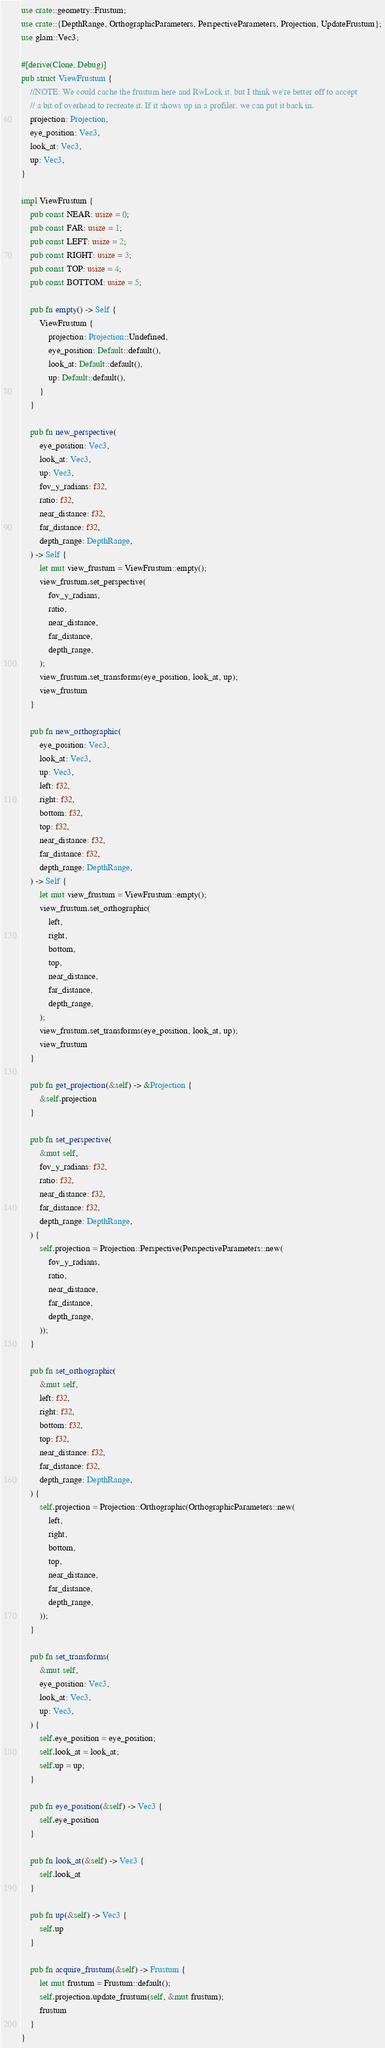<code> <loc_0><loc_0><loc_500><loc_500><_Rust_>use crate::geometry::Frustum;
use crate::{DepthRange, OrthographicParameters, PerspectiveParameters, Projection, UpdateFrustum};
use glam::Vec3;

#[derive(Clone, Debug)]
pub struct ViewFrustum {
    //NOTE: We could cache the frustum here and RwLock it, but I think we're better off to accept
    // a bit of overhead to recreate it. If it shows up in a profiler, we can put it back in.
    projection: Projection,
    eye_position: Vec3,
    look_at: Vec3,
    up: Vec3,
}

impl ViewFrustum {
    pub const NEAR: usize = 0;
    pub const FAR: usize = 1;
    pub const LEFT: usize = 2;
    pub const RIGHT: usize = 3;
    pub const TOP: usize = 4;
    pub const BOTTOM: usize = 5;

    pub fn empty() -> Self {
        ViewFrustum {
            projection: Projection::Undefined,
            eye_position: Default::default(),
            look_at: Default::default(),
            up: Default::default(),
        }
    }

    pub fn new_perspective(
        eye_position: Vec3,
        look_at: Vec3,
        up: Vec3,
        fov_y_radians: f32,
        ratio: f32,
        near_distance: f32,
        far_distance: f32,
        depth_range: DepthRange,
    ) -> Self {
        let mut view_frustum = ViewFrustum::empty();
        view_frustum.set_perspective(
            fov_y_radians,
            ratio,
            near_distance,
            far_distance,
            depth_range,
        );
        view_frustum.set_transforms(eye_position, look_at, up);
        view_frustum
    }

    pub fn new_orthographic(
        eye_position: Vec3,
        look_at: Vec3,
        up: Vec3,
        left: f32,
        right: f32,
        bottom: f32,
        top: f32,
        near_distance: f32,
        far_distance: f32,
        depth_range: DepthRange,
    ) -> Self {
        let mut view_frustum = ViewFrustum::empty();
        view_frustum.set_orthographic(
            left,
            right,
            bottom,
            top,
            near_distance,
            far_distance,
            depth_range,
        );
        view_frustum.set_transforms(eye_position, look_at, up);
        view_frustum
    }

    pub fn get_projection(&self) -> &Projection {
        &self.projection
    }

    pub fn set_perspective(
        &mut self,
        fov_y_radians: f32,
        ratio: f32,
        near_distance: f32,
        far_distance: f32,
        depth_range: DepthRange,
    ) {
        self.projection = Projection::Perspective(PerspectiveParameters::new(
            fov_y_radians,
            ratio,
            near_distance,
            far_distance,
            depth_range,
        ));
    }

    pub fn set_orthographic(
        &mut self,
        left: f32,
        right: f32,
        bottom: f32,
        top: f32,
        near_distance: f32,
        far_distance: f32,
        depth_range: DepthRange,
    ) {
        self.projection = Projection::Orthographic(OrthographicParameters::new(
            left,
            right,
            bottom,
            top,
            near_distance,
            far_distance,
            depth_range,
        ));
    }

    pub fn set_transforms(
        &mut self,
        eye_position: Vec3,
        look_at: Vec3,
        up: Vec3,
    ) {
        self.eye_position = eye_position;
        self.look_at = look_at;
        self.up = up;
    }

    pub fn eye_position(&self) -> Vec3 {
        self.eye_position
    }

    pub fn look_at(&self) -> Vec3 {
        self.look_at
    }

    pub fn up(&self) -> Vec3 {
        self.up
    }

    pub fn acquire_frustum(&self) -> Frustum {
        let mut frustum = Frustum::default();
        self.projection.update_frustum(self, &mut frustum);
        frustum
    }
}
</code> 